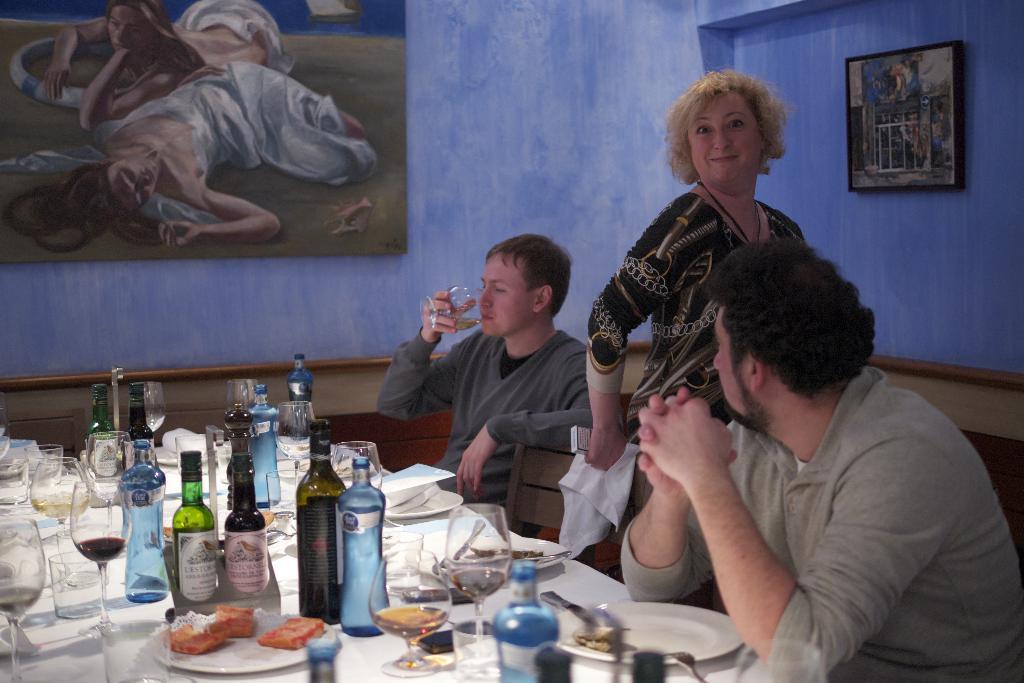In one or two sentences, can you explain what this image depicts? There are three members in this picture. Two of them were sitting in the chairs, in front of a table on which drink bottles, water bottles, glasses and some food items were placed on it. There is a woman standing and smiling. In the background there is a photograph which is attached to the wall here. 